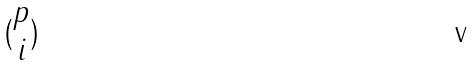Convert formula to latex. <formula><loc_0><loc_0><loc_500><loc_500>( \begin{matrix} p \\ i \end{matrix} )</formula> 